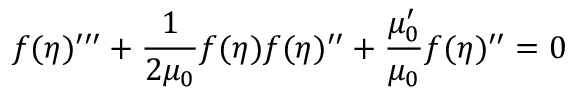<formula> <loc_0><loc_0><loc_500><loc_500>f ( \eta ) ^ { \prime \prime \prime } + \frac { 1 } { 2 \mu _ { 0 } } f ( \eta ) f ( \eta ) ^ { \prime \prime } + \frac { \mu _ { 0 } ^ { \prime } } { \mu _ { 0 } } f ( \eta ) ^ { \prime \prime } = 0</formula> 